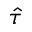<formula> <loc_0><loc_0><loc_500><loc_500>\hat { \tau }</formula> 